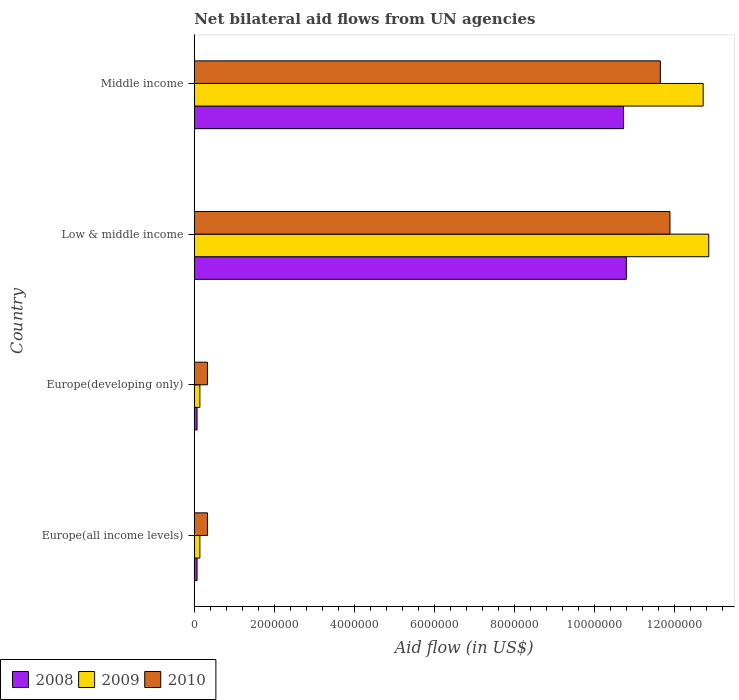How many groups of bars are there?
Offer a terse response. 4. Are the number of bars on each tick of the Y-axis equal?
Offer a terse response. Yes. How many bars are there on the 4th tick from the top?
Provide a succinct answer. 3. How many bars are there on the 2nd tick from the bottom?
Your answer should be very brief. 3. What is the label of the 1st group of bars from the top?
Provide a succinct answer. Middle income. What is the net bilateral aid flow in 2010 in Europe(all income levels)?
Keep it short and to the point. 3.30e+05. Across all countries, what is the maximum net bilateral aid flow in 2010?
Make the answer very short. 1.19e+07. In which country was the net bilateral aid flow in 2009 maximum?
Your answer should be compact. Low & middle income. In which country was the net bilateral aid flow in 2008 minimum?
Keep it short and to the point. Europe(all income levels). What is the total net bilateral aid flow in 2008 in the graph?
Your answer should be very brief. 2.17e+07. What is the difference between the net bilateral aid flow in 2008 in Europe(all income levels) and the net bilateral aid flow in 2010 in Low & middle income?
Keep it short and to the point. -1.18e+07. What is the average net bilateral aid flow in 2008 per country?
Make the answer very short. 5.42e+06. In how many countries, is the net bilateral aid flow in 2010 greater than 4400000 US$?
Your answer should be very brief. 2. What is the difference between the highest and the second highest net bilateral aid flow in 2010?
Your answer should be very brief. 2.40e+05. What is the difference between the highest and the lowest net bilateral aid flow in 2010?
Your answer should be compact. 1.16e+07. In how many countries, is the net bilateral aid flow in 2008 greater than the average net bilateral aid flow in 2008 taken over all countries?
Keep it short and to the point. 2. Is the sum of the net bilateral aid flow in 2008 in Europe(developing only) and Low & middle income greater than the maximum net bilateral aid flow in 2010 across all countries?
Provide a short and direct response. No. What does the 2nd bar from the bottom in Low & middle income represents?
Provide a short and direct response. 2009. Is it the case that in every country, the sum of the net bilateral aid flow in 2010 and net bilateral aid flow in 2008 is greater than the net bilateral aid flow in 2009?
Provide a succinct answer. Yes. Are all the bars in the graph horizontal?
Offer a very short reply. Yes. How many countries are there in the graph?
Your answer should be very brief. 4. What is the difference between two consecutive major ticks on the X-axis?
Offer a very short reply. 2.00e+06. Are the values on the major ticks of X-axis written in scientific E-notation?
Provide a short and direct response. No. Does the graph contain any zero values?
Your answer should be compact. No. Does the graph contain grids?
Provide a short and direct response. No. How many legend labels are there?
Your answer should be very brief. 3. What is the title of the graph?
Provide a succinct answer. Net bilateral aid flows from UN agencies. What is the label or title of the X-axis?
Offer a terse response. Aid flow (in US$). What is the Aid flow (in US$) in 2009 in Europe(all income levels)?
Make the answer very short. 1.40e+05. What is the Aid flow (in US$) of 2009 in Europe(developing only)?
Keep it short and to the point. 1.40e+05. What is the Aid flow (in US$) in 2008 in Low & middle income?
Ensure brevity in your answer.  1.08e+07. What is the Aid flow (in US$) in 2009 in Low & middle income?
Keep it short and to the point. 1.29e+07. What is the Aid flow (in US$) of 2010 in Low & middle income?
Provide a short and direct response. 1.19e+07. What is the Aid flow (in US$) in 2008 in Middle income?
Keep it short and to the point. 1.07e+07. What is the Aid flow (in US$) in 2009 in Middle income?
Your answer should be compact. 1.27e+07. What is the Aid flow (in US$) in 2010 in Middle income?
Ensure brevity in your answer.  1.16e+07. Across all countries, what is the maximum Aid flow (in US$) in 2008?
Keep it short and to the point. 1.08e+07. Across all countries, what is the maximum Aid flow (in US$) in 2009?
Your response must be concise. 1.29e+07. Across all countries, what is the maximum Aid flow (in US$) in 2010?
Ensure brevity in your answer.  1.19e+07. Across all countries, what is the minimum Aid flow (in US$) in 2008?
Your answer should be compact. 7.00e+04. Across all countries, what is the minimum Aid flow (in US$) of 2009?
Keep it short and to the point. 1.40e+05. Across all countries, what is the minimum Aid flow (in US$) in 2010?
Keep it short and to the point. 3.30e+05. What is the total Aid flow (in US$) in 2008 in the graph?
Offer a very short reply. 2.17e+07. What is the total Aid flow (in US$) of 2009 in the graph?
Your answer should be very brief. 2.59e+07. What is the total Aid flow (in US$) in 2010 in the graph?
Offer a terse response. 2.42e+07. What is the difference between the Aid flow (in US$) in 2008 in Europe(all income levels) and that in Low & middle income?
Provide a succinct answer. -1.07e+07. What is the difference between the Aid flow (in US$) in 2009 in Europe(all income levels) and that in Low & middle income?
Your response must be concise. -1.27e+07. What is the difference between the Aid flow (in US$) in 2010 in Europe(all income levels) and that in Low & middle income?
Keep it short and to the point. -1.16e+07. What is the difference between the Aid flow (in US$) in 2008 in Europe(all income levels) and that in Middle income?
Your answer should be compact. -1.07e+07. What is the difference between the Aid flow (in US$) in 2009 in Europe(all income levels) and that in Middle income?
Provide a succinct answer. -1.26e+07. What is the difference between the Aid flow (in US$) of 2010 in Europe(all income levels) and that in Middle income?
Give a very brief answer. -1.13e+07. What is the difference between the Aid flow (in US$) in 2008 in Europe(developing only) and that in Low & middle income?
Your response must be concise. -1.07e+07. What is the difference between the Aid flow (in US$) of 2009 in Europe(developing only) and that in Low & middle income?
Provide a short and direct response. -1.27e+07. What is the difference between the Aid flow (in US$) in 2010 in Europe(developing only) and that in Low & middle income?
Ensure brevity in your answer.  -1.16e+07. What is the difference between the Aid flow (in US$) of 2008 in Europe(developing only) and that in Middle income?
Ensure brevity in your answer.  -1.07e+07. What is the difference between the Aid flow (in US$) in 2009 in Europe(developing only) and that in Middle income?
Your answer should be compact. -1.26e+07. What is the difference between the Aid flow (in US$) of 2010 in Europe(developing only) and that in Middle income?
Provide a succinct answer. -1.13e+07. What is the difference between the Aid flow (in US$) in 2008 in Low & middle income and that in Middle income?
Your answer should be very brief. 7.00e+04. What is the difference between the Aid flow (in US$) of 2008 in Europe(all income levels) and the Aid flow (in US$) of 2009 in Europe(developing only)?
Keep it short and to the point. -7.00e+04. What is the difference between the Aid flow (in US$) of 2008 in Europe(all income levels) and the Aid flow (in US$) of 2009 in Low & middle income?
Offer a very short reply. -1.28e+07. What is the difference between the Aid flow (in US$) of 2008 in Europe(all income levels) and the Aid flow (in US$) of 2010 in Low & middle income?
Keep it short and to the point. -1.18e+07. What is the difference between the Aid flow (in US$) of 2009 in Europe(all income levels) and the Aid flow (in US$) of 2010 in Low & middle income?
Keep it short and to the point. -1.18e+07. What is the difference between the Aid flow (in US$) in 2008 in Europe(all income levels) and the Aid flow (in US$) in 2009 in Middle income?
Provide a succinct answer. -1.26e+07. What is the difference between the Aid flow (in US$) in 2008 in Europe(all income levels) and the Aid flow (in US$) in 2010 in Middle income?
Make the answer very short. -1.16e+07. What is the difference between the Aid flow (in US$) of 2009 in Europe(all income levels) and the Aid flow (in US$) of 2010 in Middle income?
Your response must be concise. -1.15e+07. What is the difference between the Aid flow (in US$) in 2008 in Europe(developing only) and the Aid flow (in US$) in 2009 in Low & middle income?
Your answer should be very brief. -1.28e+07. What is the difference between the Aid flow (in US$) in 2008 in Europe(developing only) and the Aid flow (in US$) in 2010 in Low & middle income?
Keep it short and to the point. -1.18e+07. What is the difference between the Aid flow (in US$) in 2009 in Europe(developing only) and the Aid flow (in US$) in 2010 in Low & middle income?
Make the answer very short. -1.18e+07. What is the difference between the Aid flow (in US$) of 2008 in Europe(developing only) and the Aid flow (in US$) of 2009 in Middle income?
Your answer should be compact. -1.26e+07. What is the difference between the Aid flow (in US$) of 2008 in Europe(developing only) and the Aid flow (in US$) of 2010 in Middle income?
Your answer should be very brief. -1.16e+07. What is the difference between the Aid flow (in US$) in 2009 in Europe(developing only) and the Aid flow (in US$) in 2010 in Middle income?
Your answer should be compact. -1.15e+07. What is the difference between the Aid flow (in US$) of 2008 in Low & middle income and the Aid flow (in US$) of 2009 in Middle income?
Give a very brief answer. -1.92e+06. What is the difference between the Aid flow (in US$) in 2008 in Low & middle income and the Aid flow (in US$) in 2010 in Middle income?
Keep it short and to the point. -8.50e+05. What is the difference between the Aid flow (in US$) of 2009 in Low & middle income and the Aid flow (in US$) of 2010 in Middle income?
Offer a very short reply. 1.21e+06. What is the average Aid flow (in US$) in 2008 per country?
Make the answer very short. 5.42e+06. What is the average Aid flow (in US$) of 2009 per country?
Make the answer very short. 6.46e+06. What is the average Aid flow (in US$) of 2010 per country?
Give a very brief answer. 6.05e+06. What is the difference between the Aid flow (in US$) in 2009 and Aid flow (in US$) in 2010 in Europe(all income levels)?
Keep it short and to the point. -1.90e+05. What is the difference between the Aid flow (in US$) of 2008 and Aid flow (in US$) of 2010 in Europe(developing only)?
Offer a very short reply. -2.60e+05. What is the difference between the Aid flow (in US$) of 2009 and Aid flow (in US$) of 2010 in Europe(developing only)?
Keep it short and to the point. -1.90e+05. What is the difference between the Aid flow (in US$) of 2008 and Aid flow (in US$) of 2009 in Low & middle income?
Make the answer very short. -2.06e+06. What is the difference between the Aid flow (in US$) in 2008 and Aid flow (in US$) in 2010 in Low & middle income?
Your answer should be very brief. -1.09e+06. What is the difference between the Aid flow (in US$) of 2009 and Aid flow (in US$) of 2010 in Low & middle income?
Provide a succinct answer. 9.70e+05. What is the difference between the Aid flow (in US$) of 2008 and Aid flow (in US$) of 2009 in Middle income?
Provide a succinct answer. -1.99e+06. What is the difference between the Aid flow (in US$) of 2008 and Aid flow (in US$) of 2010 in Middle income?
Provide a short and direct response. -9.20e+05. What is the difference between the Aid flow (in US$) in 2009 and Aid flow (in US$) in 2010 in Middle income?
Provide a short and direct response. 1.07e+06. What is the ratio of the Aid flow (in US$) in 2008 in Europe(all income levels) to that in Europe(developing only)?
Your answer should be very brief. 1. What is the ratio of the Aid flow (in US$) in 2009 in Europe(all income levels) to that in Europe(developing only)?
Offer a terse response. 1. What is the ratio of the Aid flow (in US$) in 2008 in Europe(all income levels) to that in Low & middle income?
Your answer should be compact. 0.01. What is the ratio of the Aid flow (in US$) in 2009 in Europe(all income levels) to that in Low & middle income?
Offer a very short reply. 0.01. What is the ratio of the Aid flow (in US$) in 2010 in Europe(all income levels) to that in Low & middle income?
Ensure brevity in your answer.  0.03. What is the ratio of the Aid flow (in US$) of 2008 in Europe(all income levels) to that in Middle income?
Offer a very short reply. 0.01. What is the ratio of the Aid flow (in US$) of 2009 in Europe(all income levels) to that in Middle income?
Offer a terse response. 0.01. What is the ratio of the Aid flow (in US$) of 2010 in Europe(all income levels) to that in Middle income?
Offer a terse response. 0.03. What is the ratio of the Aid flow (in US$) of 2008 in Europe(developing only) to that in Low & middle income?
Your response must be concise. 0.01. What is the ratio of the Aid flow (in US$) of 2009 in Europe(developing only) to that in Low & middle income?
Your answer should be compact. 0.01. What is the ratio of the Aid flow (in US$) in 2010 in Europe(developing only) to that in Low & middle income?
Give a very brief answer. 0.03. What is the ratio of the Aid flow (in US$) of 2008 in Europe(developing only) to that in Middle income?
Keep it short and to the point. 0.01. What is the ratio of the Aid flow (in US$) in 2009 in Europe(developing only) to that in Middle income?
Your answer should be compact. 0.01. What is the ratio of the Aid flow (in US$) of 2010 in Europe(developing only) to that in Middle income?
Your answer should be compact. 0.03. What is the ratio of the Aid flow (in US$) in 2008 in Low & middle income to that in Middle income?
Offer a terse response. 1.01. What is the ratio of the Aid flow (in US$) of 2010 in Low & middle income to that in Middle income?
Provide a succinct answer. 1.02. What is the difference between the highest and the second highest Aid flow (in US$) of 2010?
Ensure brevity in your answer.  2.40e+05. What is the difference between the highest and the lowest Aid flow (in US$) in 2008?
Your answer should be compact. 1.07e+07. What is the difference between the highest and the lowest Aid flow (in US$) of 2009?
Make the answer very short. 1.27e+07. What is the difference between the highest and the lowest Aid flow (in US$) of 2010?
Provide a succinct answer. 1.16e+07. 